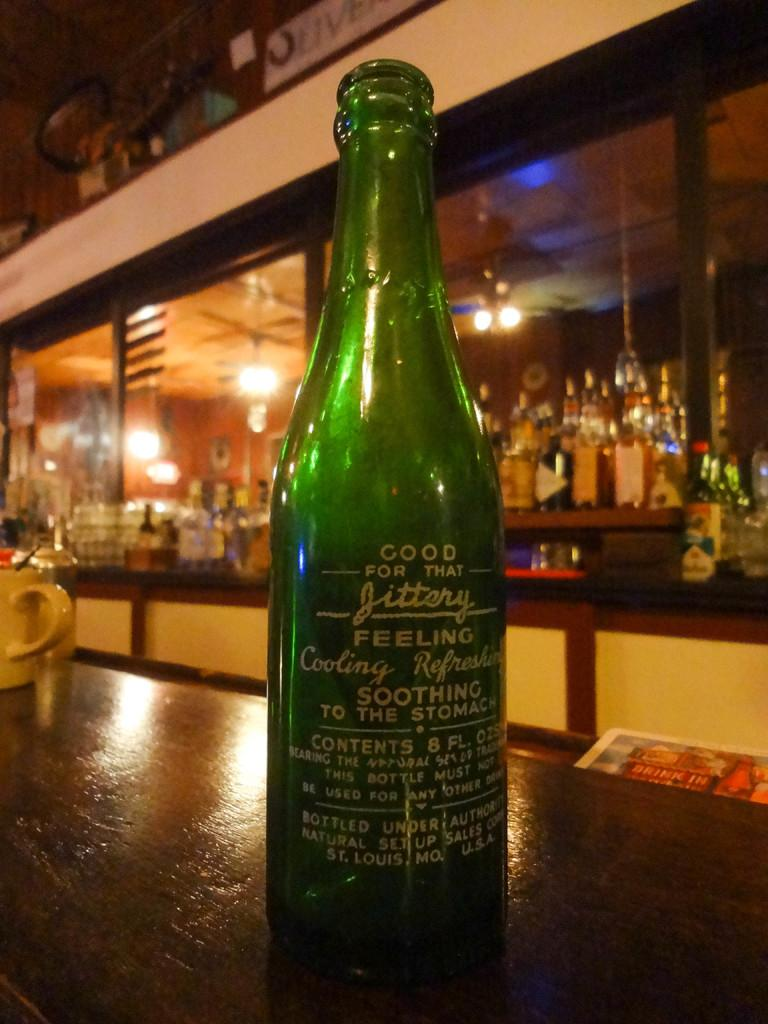<image>
Give a short and clear explanation of the subsequent image. An empty bottle with a tag that claims it is good for that jittery feeling 